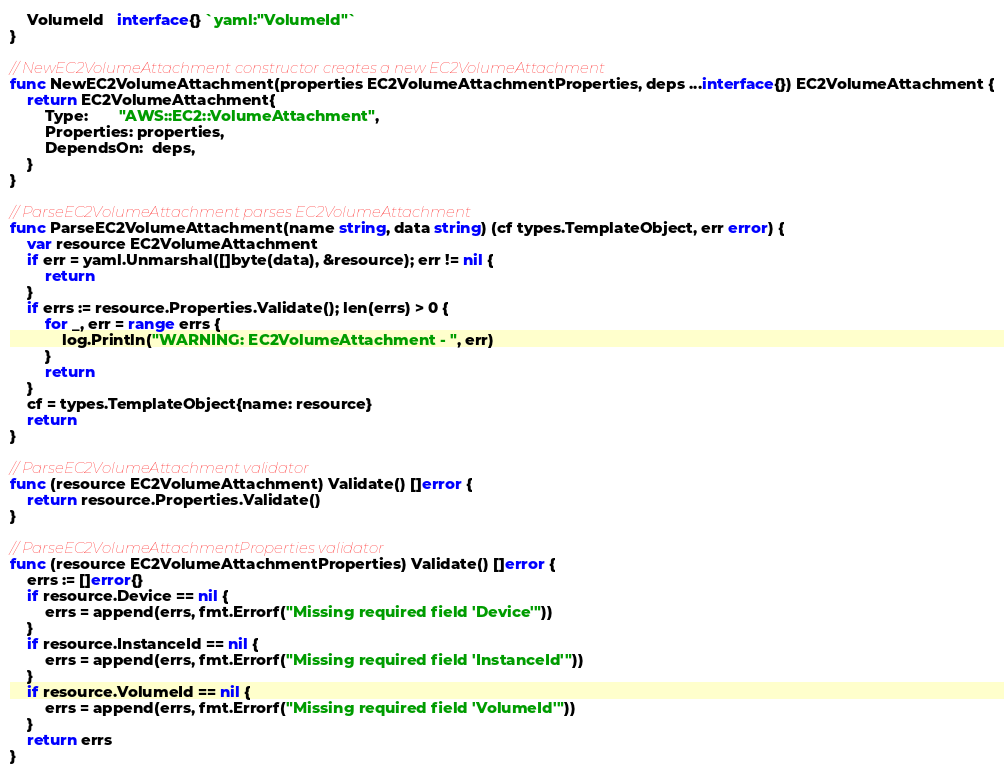Convert code to text. <code><loc_0><loc_0><loc_500><loc_500><_Go_>	VolumeId   interface{} `yaml:"VolumeId"`
}

// NewEC2VolumeAttachment constructor creates a new EC2VolumeAttachment
func NewEC2VolumeAttachment(properties EC2VolumeAttachmentProperties, deps ...interface{}) EC2VolumeAttachment {
	return EC2VolumeAttachment{
		Type:       "AWS::EC2::VolumeAttachment",
		Properties: properties,
		DependsOn:  deps,
	}
}

// ParseEC2VolumeAttachment parses EC2VolumeAttachment
func ParseEC2VolumeAttachment(name string, data string) (cf types.TemplateObject, err error) {
	var resource EC2VolumeAttachment
	if err = yaml.Unmarshal([]byte(data), &resource); err != nil {
		return
	}
	if errs := resource.Properties.Validate(); len(errs) > 0 {
		for _, err = range errs {
			log.Println("WARNING: EC2VolumeAttachment - ", err)
		}
		return
	}
	cf = types.TemplateObject{name: resource}
	return
}

// ParseEC2VolumeAttachment validator
func (resource EC2VolumeAttachment) Validate() []error {
	return resource.Properties.Validate()
}

// ParseEC2VolumeAttachmentProperties validator
func (resource EC2VolumeAttachmentProperties) Validate() []error {
	errs := []error{}
	if resource.Device == nil {
		errs = append(errs, fmt.Errorf("Missing required field 'Device'"))
	}
	if resource.InstanceId == nil {
		errs = append(errs, fmt.Errorf("Missing required field 'InstanceId'"))
	}
	if resource.VolumeId == nil {
		errs = append(errs, fmt.Errorf("Missing required field 'VolumeId'"))
	}
	return errs
}
</code> 